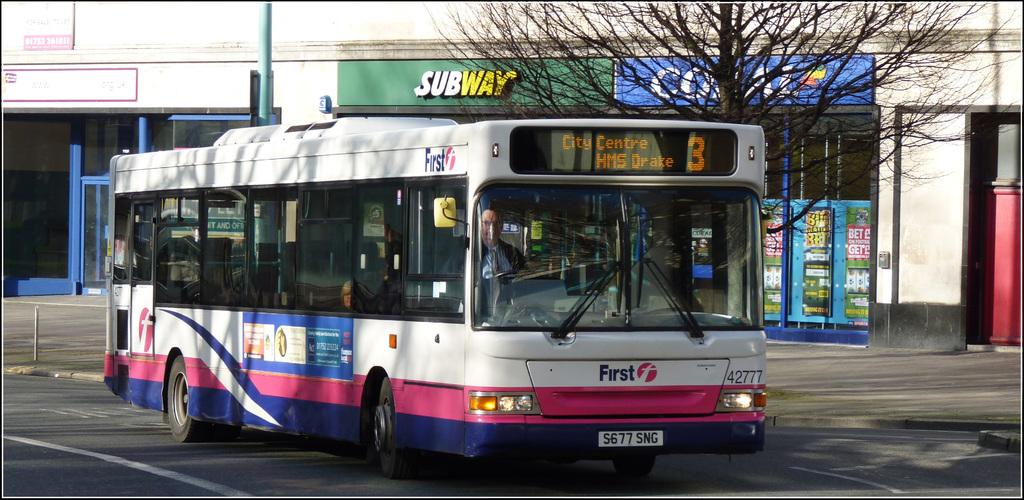<image>
Offer a succinct explanation of the picture presented. Bus 3 has just passed Subway as it drives up the road. 